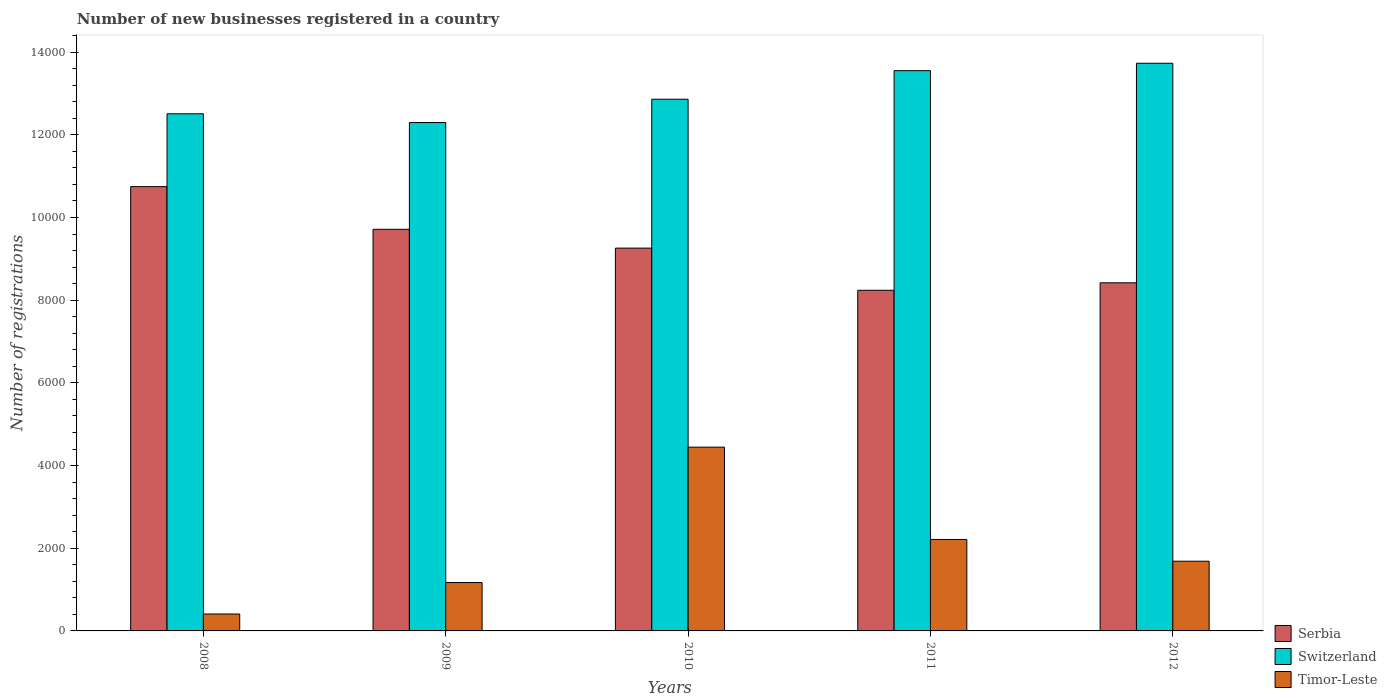How many different coloured bars are there?
Your response must be concise. 3. How many bars are there on the 1st tick from the left?
Provide a succinct answer. 3. What is the label of the 1st group of bars from the left?
Offer a terse response. 2008. What is the number of new businesses registered in Switzerland in 2008?
Offer a terse response. 1.25e+04. Across all years, what is the maximum number of new businesses registered in Switzerland?
Offer a very short reply. 1.37e+04. Across all years, what is the minimum number of new businesses registered in Timor-Leste?
Offer a very short reply. 409. In which year was the number of new businesses registered in Serbia minimum?
Keep it short and to the point. 2011. What is the total number of new businesses registered in Serbia in the graph?
Ensure brevity in your answer.  4.64e+04. What is the difference between the number of new businesses registered in Serbia in 2011 and that in 2012?
Provide a short and direct response. -181. What is the difference between the number of new businesses registered in Timor-Leste in 2011 and the number of new businesses registered in Switzerland in 2012?
Give a very brief answer. -1.15e+04. What is the average number of new businesses registered in Timor-Leste per year?
Your response must be concise. 1984.4. In the year 2009, what is the difference between the number of new businesses registered in Timor-Leste and number of new businesses registered in Serbia?
Keep it short and to the point. -8544. What is the ratio of the number of new businesses registered in Serbia in 2008 to that in 2010?
Keep it short and to the point. 1.16. Is the difference between the number of new businesses registered in Timor-Leste in 2009 and 2012 greater than the difference between the number of new businesses registered in Serbia in 2009 and 2012?
Your response must be concise. No. What is the difference between the highest and the second highest number of new businesses registered in Switzerland?
Offer a very short reply. 179. What is the difference between the highest and the lowest number of new businesses registered in Timor-Leste?
Give a very brief answer. 4036. In how many years, is the number of new businesses registered in Switzerland greater than the average number of new businesses registered in Switzerland taken over all years?
Offer a very short reply. 2. What does the 2nd bar from the left in 2011 represents?
Ensure brevity in your answer.  Switzerland. What does the 1st bar from the right in 2008 represents?
Ensure brevity in your answer.  Timor-Leste. Is it the case that in every year, the sum of the number of new businesses registered in Serbia and number of new businesses registered in Timor-Leste is greater than the number of new businesses registered in Switzerland?
Keep it short and to the point. No. Are all the bars in the graph horizontal?
Make the answer very short. No. What is the difference between two consecutive major ticks on the Y-axis?
Your response must be concise. 2000. Are the values on the major ticks of Y-axis written in scientific E-notation?
Make the answer very short. No. Does the graph contain any zero values?
Your answer should be compact. No. Does the graph contain grids?
Your answer should be compact. No. Where does the legend appear in the graph?
Provide a short and direct response. Bottom right. How many legend labels are there?
Your answer should be very brief. 3. What is the title of the graph?
Your answer should be very brief. Number of new businesses registered in a country. Does "Europe(all income levels)" appear as one of the legend labels in the graph?
Provide a succinct answer. No. What is the label or title of the Y-axis?
Your response must be concise. Number of registrations. What is the Number of registrations in Serbia in 2008?
Provide a succinct answer. 1.07e+04. What is the Number of registrations of Switzerland in 2008?
Your answer should be compact. 1.25e+04. What is the Number of registrations in Timor-Leste in 2008?
Your response must be concise. 409. What is the Number of registrations of Serbia in 2009?
Make the answer very short. 9714. What is the Number of registrations of Switzerland in 2009?
Your answer should be compact. 1.23e+04. What is the Number of registrations of Timor-Leste in 2009?
Keep it short and to the point. 1170. What is the Number of registrations in Serbia in 2010?
Offer a terse response. 9259. What is the Number of registrations in Switzerland in 2010?
Ensure brevity in your answer.  1.29e+04. What is the Number of registrations of Timor-Leste in 2010?
Make the answer very short. 4445. What is the Number of registrations in Serbia in 2011?
Your answer should be very brief. 8239. What is the Number of registrations of Switzerland in 2011?
Offer a very short reply. 1.36e+04. What is the Number of registrations in Timor-Leste in 2011?
Provide a succinct answer. 2212. What is the Number of registrations of Serbia in 2012?
Ensure brevity in your answer.  8420. What is the Number of registrations of Switzerland in 2012?
Your response must be concise. 1.37e+04. What is the Number of registrations in Timor-Leste in 2012?
Make the answer very short. 1686. Across all years, what is the maximum Number of registrations in Serbia?
Your answer should be very brief. 1.07e+04. Across all years, what is the maximum Number of registrations of Switzerland?
Offer a very short reply. 1.37e+04. Across all years, what is the maximum Number of registrations of Timor-Leste?
Give a very brief answer. 4445. Across all years, what is the minimum Number of registrations in Serbia?
Your response must be concise. 8239. Across all years, what is the minimum Number of registrations in Switzerland?
Ensure brevity in your answer.  1.23e+04. Across all years, what is the minimum Number of registrations in Timor-Leste?
Your answer should be compact. 409. What is the total Number of registrations in Serbia in the graph?
Keep it short and to the point. 4.64e+04. What is the total Number of registrations in Switzerland in the graph?
Your answer should be compact. 6.49e+04. What is the total Number of registrations of Timor-Leste in the graph?
Keep it short and to the point. 9922. What is the difference between the Number of registrations in Serbia in 2008 and that in 2009?
Give a very brief answer. 1032. What is the difference between the Number of registrations of Switzerland in 2008 and that in 2009?
Make the answer very short. 212. What is the difference between the Number of registrations of Timor-Leste in 2008 and that in 2009?
Ensure brevity in your answer.  -761. What is the difference between the Number of registrations of Serbia in 2008 and that in 2010?
Provide a short and direct response. 1487. What is the difference between the Number of registrations in Switzerland in 2008 and that in 2010?
Your answer should be compact. -352. What is the difference between the Number of registrations in Timor-Leste in 2008 and that in 2010?
Your answer should be very brief. -4036. What is the difference between the Number of registrations in Serbia in 2008 and that in 2011?
Make the answer very short. 2507. What is the difference between the Number of registrations in Switzerland in 2008 and that in 2011?
Offer a very short reply. -1043. What is the difference between the Number of registrations of Timor-Leste in 2008 and that in 2011?
Offer a very short reply. -1803. What is the difference between the Number of registrations in Serbia in 2008 and that in 2012?
Provide a succinct answer. 2326. What is the difference between the Number of registrations of Switzerland in 2008 and that in 2012?
Keep it short and to the point. -1222. What is the difference between the Number of registrations in Timor-Leste in 2008 and that in 2012?
Your answer should be very brief. -1277. What is the difference between the Number of registrations in Serbia in 2009 and that in 2010?
Ensure brevity in your answer.  455. What is the difference between the Number of registrations in Switzerland in 2009 and that in 2010?
Ensure brevity in your answer.  -564. What is the difference between the Number of registrations in Timor-Leste in 2009 and that in 2010?
Provide a succinct answer. -3275. What is the difference between the Number of registrations in Serbia in 2009 and that in 2011?
Your answer should be very brief. 1475. What is the difference between the Number of registrations of Switzerland in 2009 and that in 2011?
Ensure brevity in your answer.  -1255. What is the difference between the Number of registrations in Timor-Leste in 2009 and that in 2011?
Your response must be concise. -1042. What is the difference between the Number of registrations of Serbia in 2009 and that in 2012?
Provide a succinct answer. 1294. What is the difference between the Number of registrations of Switzerland in 2009 and that in 2012?
Your answer should be compact. -1434. What is the difference between the Number of registrations in Timor-Leste in 2009 and that in 2012?
Give a very brief answer. -516. What is the difference between the Number of registrations of Serbia in 2010 and that in 2011?
Keep it short and to the point. 1020. What is the difference between the Number of registrations in Switzerland in 2010 and that in 2011?
Offer a terse response. -691. What is the difference between the Number of registrations of Timor-Leste in 2010 and that in 2011?
Offer a very short reply. 2233. What is the difference between the Number of registrations of Serbia in 2010 and that in 2012?
Ensure brevity in your answer.  839. What is the difference between the Number of registrations of Switzerland in 2010 and that in 2012?
Keep it short and to the point. -870. What is the difference between the Number of registrations in Timor-Leste in 2010 and that in 2012?
Provide a succinct answer. 2759. What is the difference between the Number of registrations in Serbia in 2011 and that in 2012?
Keep it short and to the point. -181. What is the difference between the Number of registrations in Switzerland in 2011 and that in 2012?
Your response must be concise. -179. What is the difference between the Number of registrations of Timor-Leste in 2011 and that in 2012?
Your answer should be very brief. 526. What is the difference between the Number of registrations in Serbia in 2008 and the Number of registrations in Switzerland in 2009?
Give a very brief answer. -1550. What is the difference between the Number of registrations in Serbia in 2008 and the Number of registrations in Timor-Leste in 2009?
Provide a succinct answer. 9576. What is the difference between the Number of registrations of Switzerland in 2008 and the Number of registrations of Timor-Leste in 2009?
Your response must be concise. 1.13e+04. What is the difference between the Number of registrations in Serbia in 2008 and the Number of registrations in Switzerland in 2010?
Your response must be concise. -2114. What is the difference between the Number of registrations in Serbia in 2008 and the Number of registrations in Timor-Leste in 2010?
Make the answer very short. 6301. What is the difference between the Number of registrations in Switzerland in 2008 and the Number of registrations in Timor-Leste in 2010?
Provide a succinct answer. 8063. What is the difference between the Number of registrations in Serbia in 2008 and the Number of registrations in Switzerland in 2011?
Make the answer very short. -2805. What is the difference between the Number of registrations of Serbia in 2008 and the Number of registrations of Timor-Leste in 2011?
Give a very brief answer. 8534. What is the difference between the Number of registrations in Switzerland in 2008 and the Number of registrations in Timor-Leste in 2011?
Provide a succinct answer. 1.03e+04. What is the difference between the Number of registrations of Serbia in 2008 and the Number of registrations of Switzerland in 2012?
Offer a terse response. -2984. What is the difference between the Number of registrations in Serbia in 2008 and the Number of registrations in Timor-Leste in 2012?
Offer a terse response. 9060. What is the difference between the Number of registrations of Switzerland in 2008 and the Number of registrations of Timor-Leste in 2012?
Offer a terse response. 1.08e+04. What is the difference between the Number of registrations in Serbia in 2009 and the Number of registrations in Switzerland in 2010?
Your answer should be very brief. -3146. What is the difference between the Number of registrations of Serbia in 2009 and the Number of registrations of Timor-Leste in 2010?
Offer a terse response. 5269. What is the difference between the Number of registrations of Switzerland in 2009 and the Number of registrations of Timor-Leste in 2010?
Provide a short and direct response. 7851. What is the difference between the Number of registrations in Serbia in 2009 and the Number of registrations in Switzerland in 2011?
Offer a very short reply. -3837. What is the difference between the Number of registrations in Serbia in 2009 and the Number of registrations in Timor-Leste in 2011?
Your answer should be compact. 7502. What is the difference between the Number of registrations of Switzerland in 2009 and the Number of registrations of Timor-Leste in 2011?
Ensure brevity in your answer.  1.01e+04. What is the difference between the Number of registrations of Serbia in 2009 and the Number of registrations of Switzerland in 2012?
Offer a very short reply. -4016. What is the difference between the Number of registrations in Serbia in 2009 and the Number of registrations in Timor-Leste in 2012?
Provide a short and direct response. 8028. What is the difference between the Number of registrations of Switzerland in 2009 and the Number of registrations of Timor-Leste in 2012?
Provide a succinct answer. 1.06e+04. What is the difference between the Number of registrations of Serbia in 2010 and the Number of registrations of Switzerland in 2011?
Give a very brief answer. -4292. What is the difference between the Number of registrations of Serbia in 2010 and the Number of registrations of Timor-Leste in 2011?
Your answer should be compact. 7047. What is the difference between the Number of registrations in Switzerland in 2010 and the Number of registrations in Timor-Leste in 2011?
Keep it short and to the point. 1.06e+04. What is the difference between the Number of registrations of Serbia in 2010 and the Number of registrations of Switzerland in 2012?
Provide a short and direct response. -4471. What is the difference between the Number of registrations of Serbia in 2010 and the Number of registrations of Timor-Leste in 2012?
Keep it short and to the point. 7573. What is the difference between the Number of registrations in Switzerland in 2010 and the Number of registrations in Timor-Leste in 2012?
Provide a short and direct response. 1.12e+04. What is the difference between the Number of registrations of Serbia in 2011 and the Number of registrations of Switzerland in 2012?
Provide a succinct answer. -5491. What is the difference between the Number of registrations of Serbia in 2011 and the Number of registrations of Timor-Leste in 2012?
Your answer should be very brief. 6553. What is the difference between the Number of registrations in Switzerland in 2011 and the Number of registrations in Timor-Leste in 2012?
Your answer should be very brief. 1.19e+04. What is the average Number of registrations in Serbia per year?
Provide a short and direct response. 9275.6. What is the average Number of registrations of Switzerland per year?
Provide a short and direct response. 1.30e+04. What is the average Number of registrations of Timor-Leste per year?
Ensure brevity in your answer.  1984.4. In the year 2008, what is the difference between the Number of registrations in Serbia and Number of registrations in Switzerland?
Ensure brevity in your answer.  -1762. In the year 2008, what is the difference between the Number of registrations in Serbia and Number of registrations in Timor-Leste?
Your answer should be compact. 1.03e+04. In the year 2008, what is the difference between the Number of registrations in Switzerland and Number of registrations in Timor-Leste?
Offer a terse response. 1.21e+04. In the year 2009, what is the difference between the Number of registrations in Serbia and Number of registrations in Switzerland?
Your answer should be compact. -2582. In the year 2009, what is the difference between the Number of registrations in Serbia and Number of registrations in Timor-Leste?
Provide a short and direct response. 8544. In the year 2009, what is the difference between the Number of registrations of Switzerland and Number of registrations of Timor-Leste?
Provide a short and direct response. 1.11e+04. In the year 2010, what is the difference between the Number of registrations in Serbia and Number of registrations in Switzerland?
Provide a short and direct response. -3601. In the year 2010, what is the difference between the Number of registrations in Serbia and Number of registrations in Timor-Leste?
Your response must be concise. 4814. In the year 2010, what is the difference between the Number of registrations in Switzerland and Number of registrations in Timor-Leste?
Your answer should be very brief. 8415. In the year 2011, what is the difference between the Number of registrations in Serbia and Number of registrations in Switzerland?
Offer a terse response. -5312. In the year 2011, what is the difference between the Number of registrations of Serbia and Number of registrations of Timor-Leste?
Offer a very short reply. 6027. In the year 2011, what is the difference between the Number of registrations of Switzerland and Number of registrations of Timor-Leste?
Ensure brevity in your answer.  1.13e+04. In the year 2012, what is the difference between the Number of registrations in Serbia and Number of registrations in Switzerland?
Provide a succinct answer. -5310. In the year 2012, what is the difference between the Number of registrations of Serbia and Number of registrations of Timor-Leste?
Your answer should be compact. 6734. In the year 2012, what is the difference between the Number of registrations of Switzerland and Number of registrations of Timor-Leste?
Make the answer very short. 1.20e+04. What is the ratio of the Number of registrations of Serbia in 2008 to that in 2009?
Your answer should be compact. 1.11. What is the ratio of the Number of registrations in Switzerland in 2008 to that in 2009?
Provide a short and direct response. 1.02. What is the ratio of the Number of registrations of Timor-Leste in 2008 to that in 2009?
Offer a terse response. 0.35. What is the ratio of the Number of registrations in Serbia in 2008 to that in 2010?
Provide a short and direct response. 1.16. What is the ratio of the Number of registrations in Switzerland in 2008 to that in 2010?
Offer a terse response. 0.97. What is the ratio of the Number of registrations in Timor-Leste in 2008 to that in 2010?
Your response must be concise. 0.09. What is the ratio of the Number of registrations of Serbia in 2008 to that in 2011?
Your answer should be compact. 1.3. What is the ratio of the Number of registrations in Switzerland in 2008 to that in 2011?
Your answer should be compact. 0.92. What is the ratio of the Number of registrations in Timor-Leste in 2008 to that in 2011?
Your response must be concise. 0.18. What is the ratio of the Number of registrations in Serbia in 2008 to that in 2012?
Your response must be concise. 1.28. What is the ratio of the Number of registrations of Switzerland in 2008 to that in 2012?
Offer a very short reply. 0.91. What is the ratio of the Number of registrations of Timor-Leste in 2008 to that in 2012?
Ensure brevity in your answer.  0.24. What is the ratio of the Number of registrations in Serbia in 2009 to that in 2010?
Offer a terse response. 1.05. What is the ratio of the Number of registrations in Switzerland in 2009 to that in 2010?
Make the answer very short. 0.96. What is the ratio of the Number of registrations of Timor-Leste in 2009 to that in 2010?
Your answer should be compact. 0.26. What is the ratio of the Number of registrations of Serbia in 2009 to that in 2011?
Your answer should be very brief. 1.18. What is the ratio of the Number of registrations in Switzerland in 2009 to that in 2011?
Offer a very short reply. 0.91. What is the ratio of the Number of registrations in Timor-Leste in 2009 to that in 2011?
Ensure brevity in your answer.  0.53. What is the ratio of the Number of registrations of Serbia in 2009 to that in 2012?
Give a very brief answer. 1.15. What is the ratio of the Number of registrations in Switzerland in 2009 to that in 2012?
Offer a terse response. 0.9. What is the ratio of the Number of registrations in Timor-Leste in 2009 to that in 2012?
Provide a short and direct response. 0.69. What is the ratio of the Number of registrations in Serbia in 2010 to that in 2011?
Your response must be concise. 1.12. What is the ratio of the Number of registrations of Switzerland in 2010 to that in 2011?
Offer a very short reply. 0.95. What is the ratio of the Number of registrations in Timor-Leste in 2010 to that in 2011?
Offer a very short reply. 2.01. What is the ratio of the Number of registrations in Serbia in 2010 to that in 2012?
Give a very brief answer. 1.1. What is the ratio of the Number of registrations of Switzerland in 2010 to that in 2012?
Offer a very short reply. 0.94. What is the ratio of the Number of registrations in Timor-Leste in 2010 to that in 2012?
Your answer should be compact. 2.64. What is the ratio of the Number of registrations of Serbia in 2011 to that in 2012?
Offer a very short reply. 0.98. What is the ratio of the Number of registrations in Switzerland in 2011 to that in 2012?
Your answer should be compact. 0.99. What is the ratio of the Number of registrations of Timor-Leste in 2011 to that in 2012?
Ensure brevity in your answer.  1.31. What is the difference between the highest and the second highest Number of registrations of Serbia?
Your answer should be compact. 1032. What is the difference between the highest and the second highest Number of registrations of Switzerland?
Your answer should be compact. 179. What is the difference between the highest and the second highest Number of registrations in Timor-Leste?
Provide a succinct answer. 2233. What is the difference between the highest and the lowest Number of registrations of Serbia?
Offer a very short reply. 2507. What is the difference between the highest and the lowest Number of registrations in Switzerland?
Your answer should be very brief. 1434. What is the difference between the highest and the lowest Number of registrations of Timor-Leste?
Provide a succinct answer. 4036. 